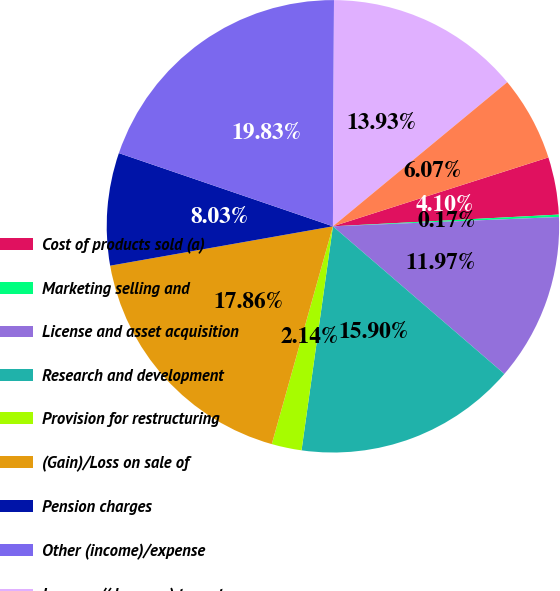Convert chart. <chart><loc_0><loc_0><loc_500><loc_500><pie_chart><fcel>Cost of products sold (a)<fcel>Marketing selling and<fcel>License and asset acquisition<fcel>Research and development<fcel>Provision for restructuring<fcel>(Gain)/Loss on sale of<fcel>Pension charges<fcel>Other (income)/expense<fcel>Increase/(decrease) to pretax<fcel>Income tax on items above<nl><fcel>4.1%<fcel>0.17%<fcel>11.97%<fcel>15.9%<fcel>2.14%<fcel>17.86%<fcel>8.03%<fcel>19.83%<fcel>13.93%<fcel>6.07%<nl></chart> 